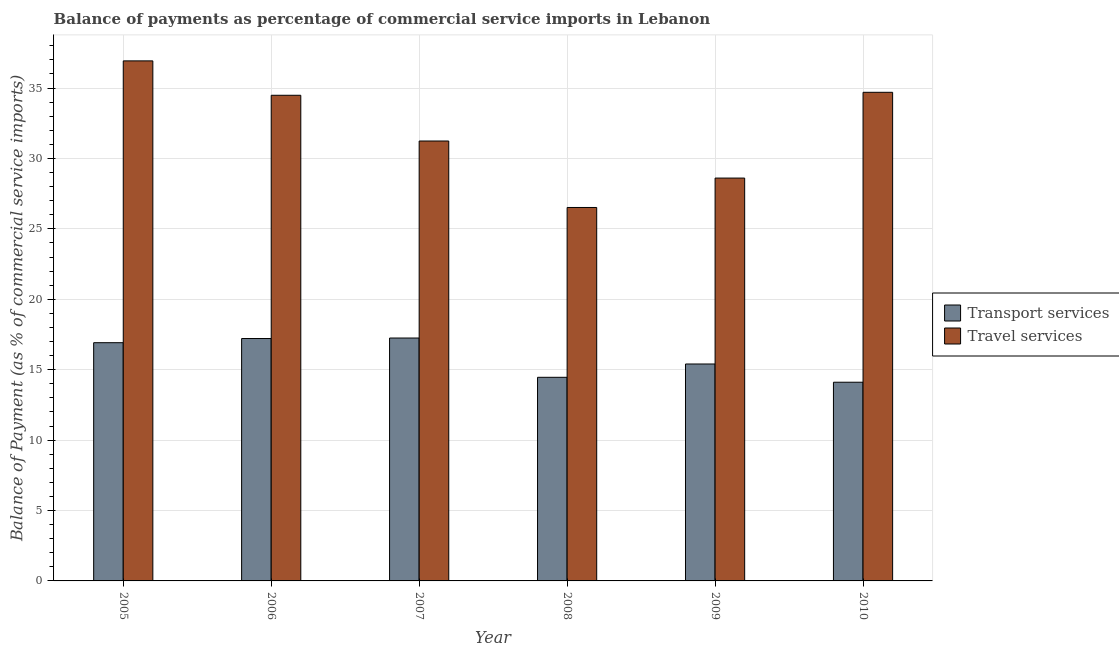How many different coloured bars are there?
Your answer should be compact. 2. How many groups of bars are there?
Your response must be concise. 6. How many bars are there on the 2nd tick from the left?
Ensure brevity in your answer.  2. How many bars are there on the 6th tick from the right?
Provide a short and direct response. 2. What is the label of the 4th group of bars from the left?
Your answer should be compact. 2008. What is the balance of payments of transport services in 2007?
Your answer should be very brief. 17.25. Across all years, what is the maximum balance of payments of transport services?
Keep it short and to the point. 17.25. Across all years, what is the minimum balance of payments of travel services?
Your answer should be very brief. 26.52. In which year was the balance of payments of travel services minimum?
Make the answer very short. 2008. What is the total balance of payments of travel services in the graph?
Offer a terse response. 192.49. What is the difference between the balance of payments of travel services in 2006 and that in 2007?
Keep it short and to the point. 3.25. What is the difference between the balance of payments of travel services in 2005 and the balance of payments of transport services in 2006?
Your answer should be compact. 2.44. What is the average balance of payments of travel services per year?
Provide a succinct answer. 32.08. In the year 2005, what is the difference between the balance of payments of travel services and balance of payments of transport services?
Provide a short and direct response. 0. In how many years, is the balance of payments of transport services greater than 22 %?
Offer a very short reply. 0. What is the ratio of the balance of payments of travel services in 2005 to that in 2009?
Ensure brevity in your answer.  1.29. Is the balance of payments of travel services in 2006 less than that in 2010?
Offer a terse response. Yes. Is the difference between the balance of payments of transport services in 2007 and 2010 greater than the difference between the balance of payments of travel services in 2007 and 2010?
Offer a very short reply. No. What is the difference between the highest and the second highest balance of payments of travel services?
Provide a succinct answer. 2.23. What is the difference between the highest and the lowest balance of payments of transport services?
Your answer should be compact. 3.14. Is the sum of the balance of payments of transport services in 2007 and 2008 greater than the maximum balance of payments of travel services across all years?
Give a very brief answer. Yes. What does the 2nd bar from the left in 2007 represents?
Offer a very short reply. Travel services. What does the 1st bar from the right in 2007 represents?
Ensure brevity in your answer.  Travel services. How many bars are there?
Provide a succinct answer. 12. Are all the bars in the graph horizontal?
Make the answer very short. No. How many years are there in the graph?
Your answer should be compact. 6. Are the values on the major ticks of Y-axis written in scientific E-notation?
Provide a short and direct response. No. Does the graph contain any zero values?
Your answer should be very brief. No. Does the graph contain grids?
Offer a terse response. Yes. Where does the legend appear in the graph?
Your answer should be very brief. Center right. What is the title of the graph?
Your response must be concise. Balance of payments as percentage of commercial service imports in Lebanon. Does "Unregistered firms" appear as one of the legend labels in the graph?
Provide a short and direct response. No. What is the label or title of the Y-axis?
Your answer should be compact. Balance of Payment (as % of commercial service imports). What is the Balance of Payment (as % of commercial service imports) of Transport services in 2005?
Your response must be concise. 16.92. What is the Balance of Payment (as % of commercial service imports) of Travel services in 2005?
Your answer should be very brief. 36.93. What is the Balance of Payment (as % of commercial service imports) in Transport services in 2006?
Provide a succinct answer. 17.21. What is the Balance of Payment (as % of commercial service imports) of Travel services in 2006?
Ensure brevity in your answer.  34.49. What is the Balance of Payment (as % of commercial service imports) in Transport services in 2007?
Offer a terse response. 17.25. What is the Balance of Payment (as % of commercial service imports) of Travel services in 2007?
Provide a succinct answer. 31.24. What is the Balance of Payment (as % of commercial service imports) in Transport services in 2008?
Offer a terse response. 14.46. What is the Balance of Payment (as % of commercial service imports) of Travel services in 2008?
Provide a succinct answer. 26.52. What is the Balance of Payment (as % of commercial service imports) in Transport services in 2009?
Your answer should be compact. 15.41. What is the Balance of Payment (as % of commercial service imports) in Travel services in 2009?
Your response must be concise. 28.61. What is the Balance of Payment (as % of commercial service imports) of Transport services in 2010?
Offer a very short reply. 14.11. What is the Balance of Payment (as % of commercial service imports) of Travel services in 2010?
Your answer should be compact. 34.7. Across all years, what is the maximum Balance of Payment (as % of commercial service imports) in Transport services?
Provide a succinct answer. 17.25. Across all years, what is the maximum Balance of Payment (as % of commercial service imports) in Travel services?
Give a very brief answer. 36.93. Across all years, what is the minimum Balance of Payment (as % of commercial service imports) in Transport services?
Keep it short and to the point. 14.11. Across all years, what is the minimum Balance of Payment (as % of commercial service imports) in Travel services?
Keep it short and to the point. 26.52. What is the total Balance of Payment (as % of commercial service imports) in Transport services in the graph?
Keep it short and to the point. 95.36. What is the total Balance of Payment (as % of commercial service imports) in Travel services in the graph?
Make the answer very short. 192.49. What is the difference between the Balance of Payment (as % of commercial service imports) of Transport services in 2005 and that in 2006?
Give a very brief answer. -0.3. What is the difference between the Balance of Payment (as % of commercial service imports) of Travel services in 2005 and that in 2006?
Provide a succinct answer. 2.44. What is the difference between the Balance of Payment (as % of commercial service imports) of Transport services in 2005 and that in 2007?
Your answer should be compact. -0.33. What is the difference between the Balance of Payment (as % of commercial service imports) of Travel services in 2005 and that in 2007?
Your answer should be compact. 5.69. What is the difference between the Balance of Payment (as % of commercial service imports) of Transport services in 2005 and that in 2008?
Provide a succinct answer. 2.46. What is the difference between the Balance of Payment (as % of commercial service imports) of Travel services in 2005 and that in 2008?
Your answer should be compact. 10.41. What is the difference between the Balance of Payment (as % of commercial service imports) in Transport services in 2005 and that in 2009?
Offer a very short reply. 1.51. What is the difference between the Balance of Payment (as % of commercial service imports) of Travel services in 2005 and that in 2009?
Give a very brief answer. 8.32. What is the difference between the Balance of Payment (as % of commercial service imports) of Transport services in 2005 and that in 2010?
Your response must be concise. 2.81. What is the difference between the Balance of Payment (as % of commercial service imports) of Travel services in 2005 and that in 2010?
Offer a terse response. 2.23. What is the difference between the Balance of Payment (as % of commercial service imports) in Transport services in 2006 and that in 2007?
Your answer should be very brief. -0.04. What is the difference between the Balance of Payment (as % of commercial service imports) in Travel services in 2006 and that in 2007?
Make the answer very short. 3.25. What is the difference between the Balance of Payment (as % of commercial service imports) of Transport services in 2006 and that in 2008?
Provide a succinct answer. 2.75. What is the difference between the Balance of Payment (as % of commercial service imports) of Travel services in 2006 and that in 2008?
Your answer should be very brief. 7.97. What is the difference between the Balance of Payment (as % of commercial service imports) of Transport services in 2006 and that in 2009?
Ensure brevity in your answer.  1.81. What is the difference between the Balance of Payment (as % of commercial service imports) of Travel services in 2006 and that in 2009?
Your answer should be compact. 5.88. What is the difference between the Balance of Payment (as % of commercial service imports) in Transport services in 2006 and that in 2010?
Make the answer very short. 3.1. What is the difference between the Balance of Payment (as % of commercial service imports) of Travel services in 2006 and that in 2010?
Provide a short and direct response. -0.21. What is the difference between the Balance of Payment (as % of commercial service imports) in Transport services in 2007 and that in 2008?
Provide a short and direct response. 2.79. What is the difference between the Balance of Payment (as % of commercial service imports) in Travel services in 2007 and that in 2008?
Your answer should be very brief. 4.72. What is the difference between the Balance of Payment (as % of commercial service imports) of Transport services in 2007 and that in 2009?
Your answer should be very brief. 1.84. What is the difference between the Balance of Payment (as % of commercial service imports) in Travel services in 2007 and that in 2009?
Provide a short and direct response. 2.63. What is the difference between the Balance of Payment (as % of commercial service imports) in Transport services in 2007 and that in 2010?
Give a very brief answer. 3.14. What is the difference between the Balance of Payment (as % of commercial service imports) in Travel services in 2007 and that in 2010?
Your answer should be compact. -3.46. What is the difference between the Balance of Payment (as % of commercial service imports) of Transport services in 2008 and that in 2009?
Your answer should be compact. -0.95. What is the difference between the Balance of Payment (as % of commercial service imports) in Travel services in 2008 and that in 2009?
Keep it short and to the point. -2.09. What is the difference between the Balance of Payment (as % of commercial service imports) of Transport services in 2008 and that in 2010?
Provide a succinct answer. 0.35. What is the difference between the Balance of Payment (as % of commercial service imports) of Travel services in 2008 and that in 2010?
Provide a short and direct response. -8.18. What is the difference between the Balance of Payment (as % of commercial service imports) of Transport services in 2009 and that in 2010?
Ensure brevity in your answer.  1.3. What is the difference between the Balance of Payment (as % of commercial service imports) in Travel services in 2009 and that in 2010?
Provide a succinct answer. -6.09. What is the difference between the Balance of Payment (as % of commercial service imports) of Transport services in 2005 and the Balance of Payment (as % of commercial service imports) of Travel services in 2006?
Give a very brief answer. -17.57. What is the difference between the Balance of Payment (as % of commercial service imports) in Transport services in 2005 and the Balance of Payment (as % of commercial service imports) in Travel services in 2007?
Your answer should be compact. -14.32. What is the difference between the Balance of Payment (as % of commercial service imports) in Transport services in 2005 and the Balance of Payment (as % of commercial service imports) in Travel services in 2008?
Provide a succinct answer. -9.6. What is the difference between the Balance of Payment (as % of commercial service imports) of Transport services in 2005 and the Balance of Payment (as % of commercial service imports) of Travel services in 2009?
Give a very brief answer. -11.69. What is the difference between the Balance of Payment (as % of commercial service imports) of Transport services in 2005 and the Balance of Payment (as % of commercial service imports) of Travel services in 2010?
Ensure brevity in your answer.  -17.78. What is the difference between the Balance of Payment (as % of commercial service imports) in Transport services in 2006 and the Balance of Payment (as % of commercial service imports) in Travel services in 2007?
Make the answer very short. -14.03. What is the difference between the Balance of Payment (as % of commercial service imports) of Transport services in 2006 and the Balance of Payment (as % of commercial service imports) of Travel services in 2008?
Provide a short and direct response. -9.31. What is the difference between the Balance of Payment (as % of commercial service imports) in Transport services in 2006 and the Balance of Payment (as % of commercial service imports) in Travel services in 2009?
Your response must be concise. -11.39. What is the difference between the Balance of Payment (as % of commercial service imports) in Transport services in 2006 and the Balance of Payment (as % of commercial service imports) in Travel services in 2010?
Ensure brevity in your answer.  -17.49. What is the difference between the Balance of Payment (as % of commercial service imports) in Transport services in 2007 and the Balance of Payment (as % of commercial service imports) in Travel services in 2008?
Your answer should be compact. -9.27. What is the difference between the Balance of Payment (as % of commercial service imports) in Transport services in 2007 and the Balance of Payment (as % of commercial service imports) in Travel services in 2009?
Offer a terse response. -11.36. What is the difference between the Balance of Payment (as % of commercial service imports) in Transport services in 2007 and the Balance of Payment (as % of commercial service imports) in Travel services in 2010?
Your answer should be compact. -17.45. What is the difference between the Balance of Payment (as % of commercial service imports) of Transport services in 2008 and the Balance of Payment (as % of commercial service imports) of Travel services in 2009?
Your response must be concise. -14.15. What is the difference between the Balance of Payment (as % of commercial service imports) in Transport services in 2008 and the Balance of Payment (as % of commercial service imports) in Travel services in 2010?
Give a very brief answer. -20.24. What is the difference between the Balance of Payment (as % of commercial service imports) in Transport services in 2009 and the Balance of Payment (as % of commercial service imports) in Travel services in 2010?
Provide a succinct answer. -19.29. What is the average Balance of Payment (as % of commercial service imports) of Transport services per year?
Provide a succinct answer. 15.89. What is the average Balance of Payment (as % of commercial service imports) in Travel services per year?
Your response must be concise. 32.08. In the year 2005, what is the difference between the Balance of Payment (as % of commercial service imports) of Transport services and Balance of Payment (as % of commercial service imports) of Travel services?
Make the answer very short. -20.01. In the year 2006, what is the difference between the Balance of Payment (as % of commercial service imports) of Transport services and Balance of Payment (as % of commercial service imports) of Travel services?
Your response must be concise. -17.27. In the year 2007, what is the difference between the Balance of Payment (as % of commercial service imports) in Transport services and Balance of Payment (as % of commercial service imports) in Travel services?
Provide a succinct answer. -13.99. In the year 2008, what is the difference between the Balance of Payment (as % of commercial service imports) of Transport services and Balance of Payment (as % of commercial service imports) of Travel services?
Your answer should be very brief. -12.06. In the year 2009, what is the difference between the Balance of Payment (as % of commercial service imports) of Transport services and Balance of Payment (as % of commercial service imports) of Travel services?
Offer a very short reply. -13.2. In the year 2010, what is the difference between the Balance of Payment (as % of commercial service imports) in Transport services and Balance of Payment (as % of commercial service imports) in Travel services?
Your answer should be very brief. -20.59. What is the ratio of the Balance of Payment (as % of commercial service imports) of Transport services in 2005 to that in 2006?
Offer a terse response. 0.98. What is the ratio of the Balance of Payment (as % of commercial service imports) in Travel services in 2005 to that in 2006?
Offer a terse response. 1.07. What is the ratio of the Balance of Payment (as % of commercial service imports) of Transport services in 2005 to that in 2007?
Keep it short and to the point. 0.98. What is the ratio of the Balance of Payment (as % of commercial service imports) in Travel services in 2005 to that in 2007?
Offer a terse response. 1.18. What is the ratio of the Balance of Payment (as % of commercial service imports) of Transport services in 2005 to that in 2008?
Offer a terse response. 1.17. What is the ratio of the Balance of Payment (as % of commercial service imports) of Travel services in 2005 to that in 2008?
Your response must be concise. 1.39. What is the ratio of the Balance of Payment (as % of commercial service imports) of Transport services in 2005 to that in 2009?
Make the answer very short. 1.1. What is the ratio of the Balance of Payment (as % of commercial service imports) of Travel services in 2005 to that in 2009?
Your answer should be very brief. 1.29. What is the ratio of the Balance of Payment (as % of commercial service imports) of Transport services in 2005 to that in 2010?
Provide a short and direct response. 1.2. What is the ratio of the Balance of Payment (as % of commercial service imports) of Travel services in 2005 to that in 2010?
Your answer should be compact. 1.06. What is the ratio of the Balance of Payment (as % of commercial service imports) of Transport services in 2006 to that in 2007?
Your response must be concise. 1. What is the ratio of the Balance of Payment (as % of commercial service imports) of Travel services in 2006 to that in 2007?
Your answer should be very brief. 1.1. What is the ratio of the Balance of Payment (as % of commercial service imports) in Transport services in 2006 to that in 2008?
Offer a very short reply. 1.19. What is the ratio of the Balance of Payment (as % of commercial service imports) in Travel services in 2006 to that in 2008?
Provide a succinct answer. 1.3. What is the ratio of the Balance of Payment (as % of commercial service imports) in Transport services in 2006 to that in 2009?
Your answer should be compact. 1.12. What is the ratio of the Balance of Payment (as % of commercial service imports) in Travel services in 2006 to that in 2009?
Provide a short and direct response. 1.21. What is the ratio of the Balance of Payment (as % of commercial service imports) in Transport services in 2006 to that in 2010?
Your response must be concise. 1.22. What is the ratio of the Balance of Payment (as % of commercial service imports) in Transport services in 2007 to that in 2008?
Keep it short and to the point. 1.19. What is the ratio of the Balance of Payment (as % of commercial service imports) in Travel services in 2007 to that in 2008?
Make the answer very short. 1.18. What is the ratio of the Balance of Payment (as % of commercial service imports) of Transport services in 2007 to that in 2009?
Provide a succinct answer. 1.12. What is the ratio of the Balance of Payment (as % of commercial service imports) of Travel services in 2007 to that in 2009?
Your answer should be very brief. 1.09. What is the ratio of the Balance of Payment (as % of commercial service imports) of Transport services in 2007 to that in 2010?
Offer a very short reply. 1.22. What is the ratio of the Balance of Payment (as % of commercial service imports) of Travel services in 2007 to that in 2010?
Provide a short and direct response. 0.9. What is the ratio of the Balance of Payment (as % of commercial service imports) in Transport services in 2008 to that in 2009?
Provide a short and direct response. 0.94. What is the ratio of the Balance of Payment (as % of commercial service imports) of Travel services in 2008 to that in 2009?
Your answer should be very brief. 0.93. What is the ratio of the Balance of Payment (as % of commercial service imports) in Transport services in 2008 to that in 2010?
Provide a succinct answer. 1.02. What is the ratio of the Balance of Payment (as % of commercial service imports) of Travel services in 2008 to that in 2010?
Give a very brief answer. 0.76. What is the ratio of the Balance of Payment (as % of commercial service imports) of Transport services in 2009 to that in 2010?
Your answer should be compact. 1.09. What is the ratio of the Balance of Payment (as % of commercial service imports) in Travel services in 2009 to that in 2010?
Make the answer very short. 0.82. What is the difference between the highest and the second highest Balance of Payment (as % of commercial service imports) in Transport services?
Give a very brief answer. 0.04. What is the difference between the highest and the second highest Balance of Payment (as % of commercial service imports) of Travel services?
Your response must be concise. 2.23. What is the difference between the highest and the lowest Balance of Payment (as % of commercial service imports) in Transport services?
Ensure brevity in your answer.  3.14. What is the difference between the highest and the lowest Balance of Payment (as % of commercial service imports) of Travel services?
Offer a very short reply. 10.41. 